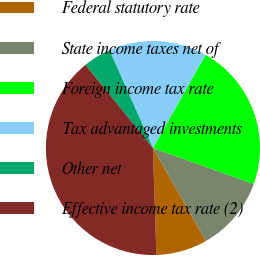Convert chart to OTSL. <chart><loc_0><loc_0><loc_500><loc_500><pie_chart><fcel>Federal statutory rate<fcel>State income taxes net of<fcel>Foreign income tax rate<fcel>Tax advantaged investments<fcel>Other net<fcel>Effective income tax rate (2)<nl><fcel>7.74%<fcel>11.29%<fcel>22.28%<fcel>14.83%<fcel>4.19%<fcel>39.67%<nl></chart> 